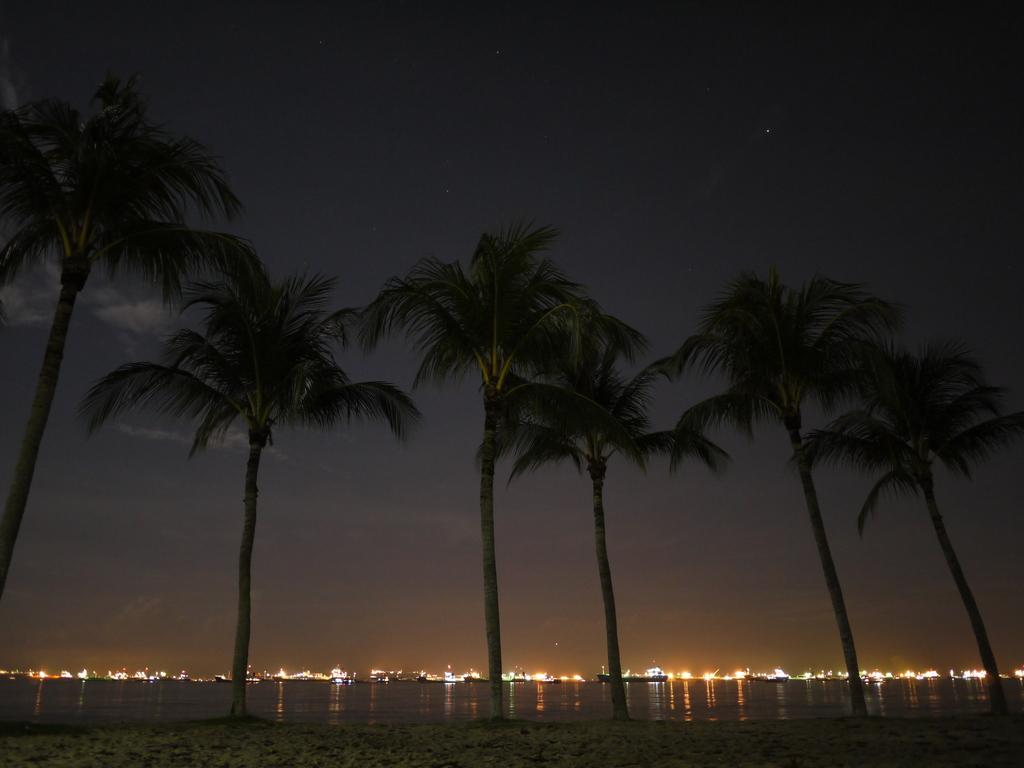What is located in the center of the image? There are trees in the center of the image. What type of natural feature can be seen in the image? There is water visible in the image. What is present at the bottom of the image? There is sand at the bottom of the image. What can be seen in the background of the image? There are lights in the background of the image. What is visible above the trees and lights? There is sky visible in the image. How many cats are sitting on the butter in the image? There are no cats or butter present in the image. What type of list is being used to organize the items in the image? There is no list present in the image; it features trees, water, sand, lights, and sky. 